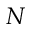Convert formula to latex. <formula><loc_0><loc_0><loc_500><loc_500>N</formula> 